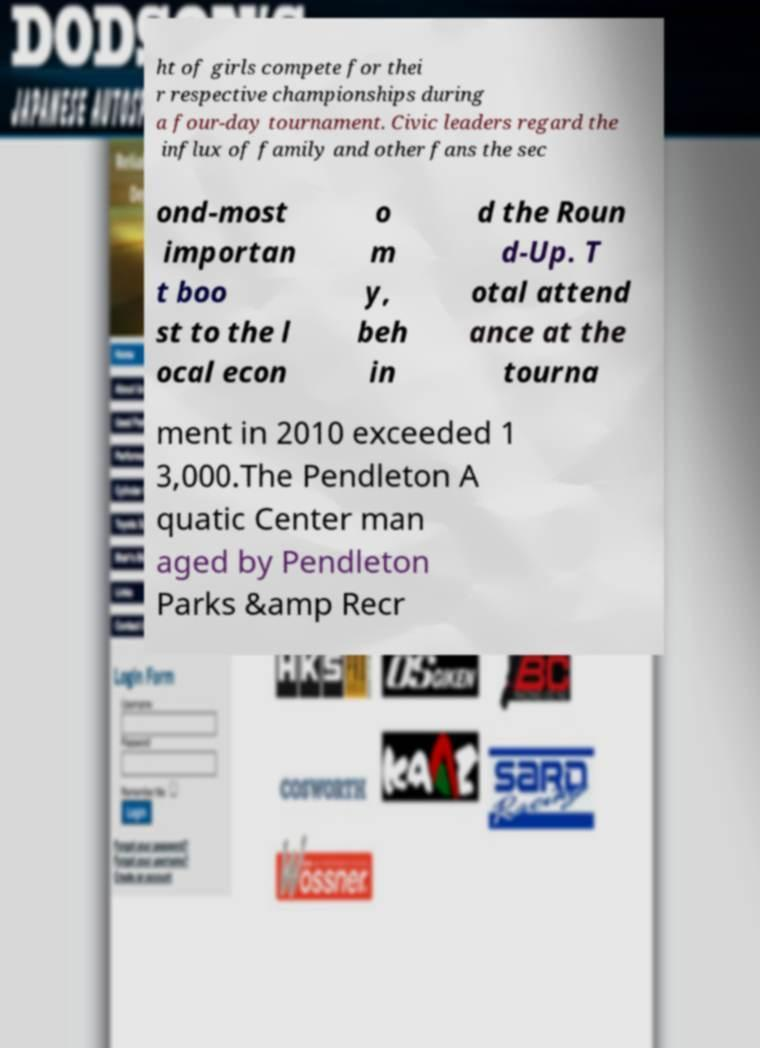What messages or text are displayed in this image? I need them in a readable, typed format. ht of girls compete for thei r respective championships during a four-day tournament. Civic leaders regard the influx of family and other fans the sec ond-most importan t boo st to the l ocal econ o m y, beh in d the Roun d-Up. T otal attend ance at the tourna ment in 2010 exceeded 1 3,000.The Pendleton A quatic Center man aged by Pendleton Parks &amp Recr 